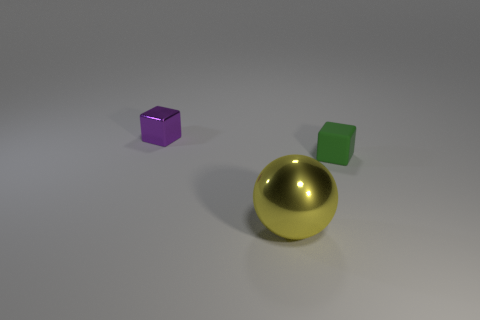Add 2 small green blocks. How many objects exist? 5 Subtract all blocks. How many objects are left? 1 Subtract 0 red cylinders. How many objects are left? 3 Subtract all big gray balls. Subtract all green objects. How many objects are left? 2 Add 2 tiny green objects. How many tiny green objects are left? 3 Add 3 large red cylinders. How many large red cylinders exist? 3 